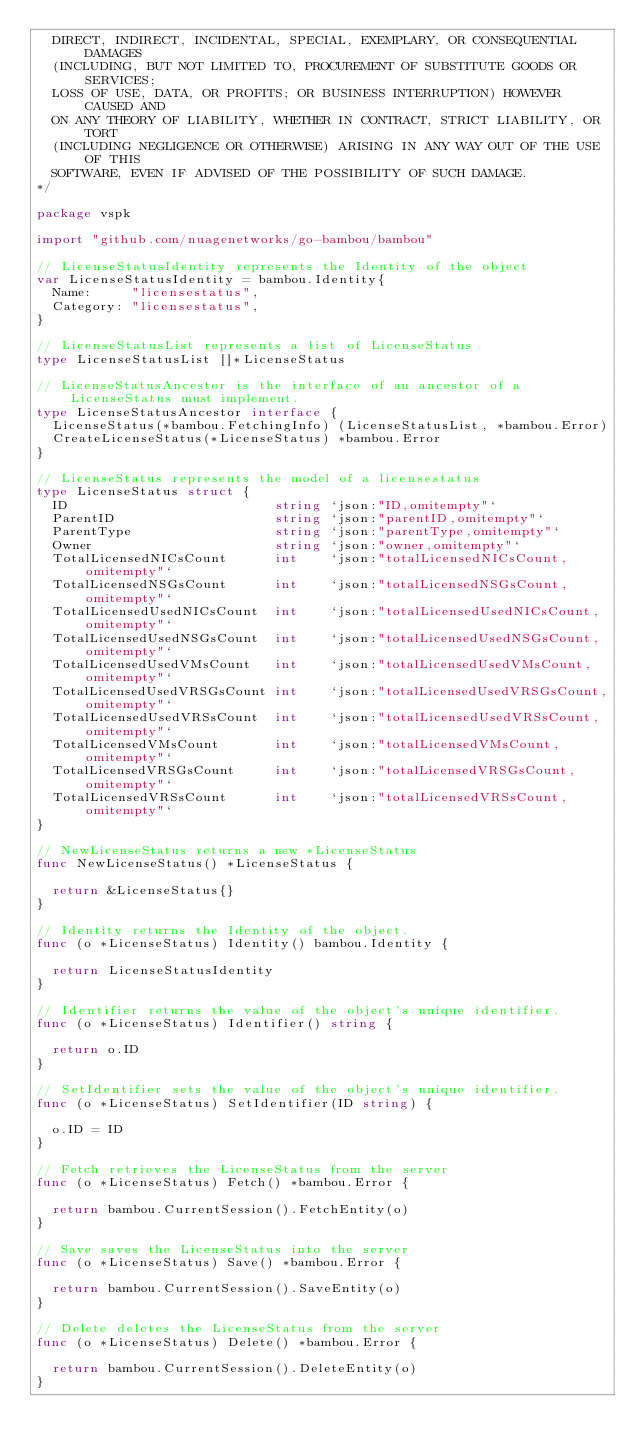Convert code to text. <code><loc_0><loc_0><loc_500><loc_500><_Go_>  DIRECT, INDIRECT, INCIDENTAL, SPECIAL, EXEMPLARY, OR CONSEQUENTIAL DAMAGES
  (INCLUDING, BUT NOT LIMITED TO, PROCUREMENT OF SUBSTITUTE GOODS OR SERVICES;
  LOSS OF USE, DATA, OR PROFITS; OR BUSINESS INTERRUPTION) HOWEVER CAUSED AND
  ON ANY THEORY OF LIABILITY, WHETHER IN CONTRACT, STRICT LIABILITY, OR TORT
  (INCLUDING NEGLIGENCE OR OTHERWISE) ARISING IN ANY WAY OUT OF THE USE OF THIS
  SOFTWARE, EVEN IF ADVISED OF THE POSSIBILITY OF SUCH DAMAGE.
*/

package vspk

import "github.com/nuagenetworks/go-bambou/bambou"

// LicenseStatusIdentity represents the Identity of the object
var LicenseStatusIdentity = bambou.Identity{
	Name:     "licensestatus",
	Category: "licensestatus",
}

// LicenseStatusList represents a list of LicenseStatus
type LicenseStatusList []*LicenseStatus

// LicenseStatusAncestor is the interface of an ancestor of a LicenseStatus must implement.
type LicenseStatusAncestor interface {
	LicenseStatus(*bambou.FetchingInfo) (LicenseStatusList, *bambou.Error)
	CreateLicenseStatus(*LicenseStatus) *bambou.Error
}

// LicenseStatus represents the model of a licensestatus
type LicenseStatus struct {
	ID                          string `json:"ID,omitempty"`
	ParentID                    string `json:"parentID,omitempty"`
	ParentType                  string `json:"parentType,omitempty"`
	Owner                       string `json:"owner,omitempty"`
	TotalLicensedNICsCount      int    `json:"totalLicensedNICsCount,omitempty"`
	TotalLicensedNSGsCount      int    `json:"totalLicensedNSGsCount,omitempty"`
	TotalLicensedUsedNICsCount  int    `json:"totalLicensedUsedNICsCount,omitempty"`
	TotalLicensedUsedNSGsCount  int    `json:"totalLicensedUsedNSGsCount,omitempty"`
	TotalLicensedUsedVMsCount   int    `json:"totalLicensedUsedVMsCount,omitempty"`
	TotalLicensedUsedVRSGsCount int    `json:"totalLicensedUsedVRSGsCount,omitempty"`
	TotalLicensedUsedVRSsCount  int    `json:"totalLicensedUsedVRSsCount,omitempty"`
	TotalLicensedVMsCount       int    `json:"totalLicensedVMsCount,omitempty"`
	TotalLicensedVRSGsCount     int    `json:"totalLicensedVRSGsCount,omitempty"`
	TotalLicensedVRSsCount      int    `json:"totalLicensedVRSsCount,omitempty"`
}

// NewLicenseStatus returns a new *LicenseStatus
func NewLicenseStatus() *LicenseStatus {

	return &LicenseStatus{}
}

// Identity returns the Identity of the object.
func (o *LicenseStatus) Identity() bambou.Identity {

	return LicenseStatusIdentity
}

// Identifier returns the value of the object's unique identifier.
func (o *LicenseStatus) Identifier() string {

	return o.ID
}

// SetIdentifier sets the value of the object's unique identifier.
func (o *LicenseStatus) SetIdentifier(ID string) {

	o.ID = ID
}

// Fetch retrieves the LicenseStatus from the server
func (o *LicenseStatus) Fetch() *bambou.Error {

	return bambou.CurrentSession().FetchEntity(o)
}

// Save saves the LicenseStatus into the server
func (o *LicenseStatus) Save() *bambou.Error {

	return bambou.CurrentSession().SaveEntity(o)
}

// Delete deletes the LicenseStatus from the server
func (o *LicenseStatus) Delete() *bambou.Error {

	return bambou.CurrentSession().DeleteEntity(o)
}
</code> 